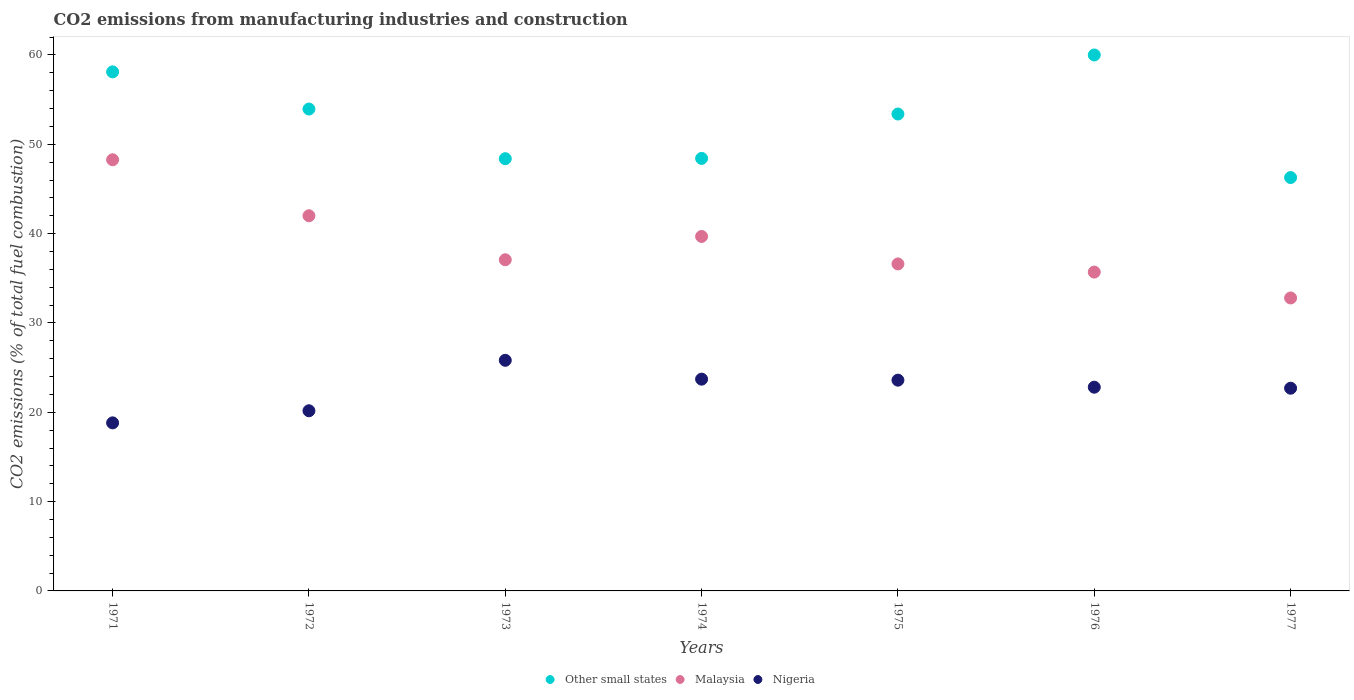How many different coloured dotlines are there?
Offer a terse response. 3. What is the amount of CO2 emitted in Nigeria in 1977?
Your response must be concise. 22.69. Across all years, what is the maximum amount of CO2 emitted in Malaysia?
Keep it short and to the point. 48.27. Across all years, what is the minimum amount of CO2 emitted in Other small states?
Keep it short and to the point. 46.28. What is the total amount of CO2 emitted in Malaysia in the graph?
Make the answer very short. 272.12. What is the difference between the amount of CO2 emitted in Other small states in 1974 and that in 1977?
Offer a very short reply. 2.14. What is the difference between the amount of CO2 emitted in Nigeria in 1971 and the amount of CO2 emitted in Other small states in 1976?
Make the answer very short. -41.19. What is the average amount of CO2 emitted in Malaysia per year?
Provide a succinct answer. 38.87. In the year 1975, what is the difference between the amount of CO2 emitted in Malaysia and amount of CO2 emitted in Nigeria?
Make the answer very short. 13.01. What is the ratio of the amount of CO2 emitted in Other small states in 1973 to that in 1976?
Make the answer very short. 0.81. Is the difference between the amount of CO2 emitted in Malaysia in 1975 and 1977 greater than the difference between the amount of CO2 emitted in Nigeria in 1975 and 1977?
Your answer should be compact. Yes. What is the difference between the highest and the second highest amount of CO2 emitted in Malaysia?
Provide a short and direct response. 6.27. What is the difference between the highest and the lowest amount of CO2 emitted in Malaysia?
Make the answer very short. 15.47. Is it the case that in every year, the sum of the amount of CO2 emitted in Malaysia and amount of CO2 emitted in Other small states  is greater than the amount of CO2 emitted in Nigeria?
Provide a short and direct response. Yes. Does the amount of CO2 emitted in Other small states monotonically increase over the years?
Keep it short and to the point. No. What is the difference between two consecutive major ticks on the Y-axis?
Your answer should be compact. 10. Are the values on the major ticks of Y-axis written in scientific E-notation?
Give a very brief answer. No. Does the graph contain any zero values?
Your response must be concise. No. How are the legend labels stacked?
Offer a very short reply. Horizontal. What is the title of the graph?
Offer a very short reply. CO2 emissions from manufacturing industries and construction. Does "Moldova" appear as one of the legend labels in the graph?
Provide a succinct answer. No. What is the label or title of the X-axis?
Ensure brevity in your answer.  Years. What is the label or title of the Y-axis?
Offer a very short reply. CO2 emissions (% of total fuel combustion). What is the CO2 emissions (% of total fuel combustion) of Other small states in 1971?
Your answer should be compact. 58.11. What is the CO2 emissions (% of total fuel combustion) in Malaysia in 1971?
Your response must be concise. 48.27. What is the CO2 emissions (% of total fuel combustion) of Nigeria in 1971?
Make the answer very short. 18.81. What is the CO2 emissions (% of total fuel combustion) in Other small states in 1972?
Your response must be concise. 53.95. What is the CO2 emissions (% of total fuel combustion) of Nigeria in 1972?
Give a very brief answer. 20.17. What is the CO2 emissions (% of total fuel combustion) in Other small states in 1973?
Give a very brief answer. 48.39. What is the CO2 emissions (% of total fuel combustion) of Malaysia in 1973?
Offer a very short reply. 37.07. What is the CO2 emissions (% of total fuel combustion) of Nigeria in 1973?
Give a very brief answer. 25.82. What is the CO2 emissions (% of total fuel combustion) of Other small states in 1974?
Your answer should be compact. 48.42. What is the CO2 emissions (% of total fuel combustion) of Malaysia in 1974?
Your answer should be compact. 39.68. What is the CO2 emissions (% of total fuel combustion) in Nigeria in 1974?
Give a very brief answer. 23.71. What is the CO2 emissions (% of total fuel combustion) in Other small states in 1975?
Your answer should be very brief. 53.39. What is the CO2 emissions (% of total fuel combustion) in Malaysia in 1975?
Offer a terse response. 36.61. What is the CO2 emissions (% of total fuel combustion) in Nigeria in 1975?
Make the answer very short. 23.59. What is the CO2 emissions (% of total fuel combustion) in Malaysia in 1976?
Keep it short and to the point. 35.69. What is the CO2 emissions (% of total fuel combustion) in Nigeria in 1976?
Ensure brevity in your answer.  22.81. What is the CO2 emissions (% of total fuel combustion) of Other small states in 1977?
Offer a very short reply. 46.28. What is the CO2 emissions (% of total fuel combustion) in Malaysia in 1977?
Make the answer very short. 32.8. What is the CO2 emissions (% of total fuel combustion) in Nigeria in 1977?
Keep it short and to the point. 22.69. Across all years, what is the maximum CO2 emissions (% of total fuel combustion) of Other small states?
Your response must be concise. 60. Across all years, what is the maximum CO2 emissions (% of total fuel combustion) of Malaysia?
Provide a succinct answer. 48.27. Across all years, what is the maximum CO2 emissions (% of total fuel combustion) in Nigeria?
Ensure brevity in your answer.  25.82. Across all years, what is the minimum CO2 emissions (% of total fuel combustion) in Other small states?
Your response must be concise. 46.28. Across all years, what is the minimum CO2 emissions (% of total fuel combustion) of Malaysia?
Your answer should be compact. 32.8. Across all years, what is the minimum CO2 emissions (% of total fuel combustion) in Nigeria?
Make the answer very short. 18.81. What is the total CO2 emissions (% of total fuel combustion) of Other small states in the graph?
Provide a short and direct response. 368.53. What is the total CO2 emissions (% of total fuel combustion) in Malaysia in the graph?
Provide a succinct answer. 272.12. What is the total CO2 emissions (% of total fuel combustion) in Nigeria in the graph?
Offer a very short reply. 157.6. What is the difference between the CO2 emissions (% of total fuel combustion) of Other small states in 1971 and that in 1972?
Provide a short and direct response. 4.16. What is the difference between the CO2 emissions (% of total fuel combustion) of Malaysia in 1971 and that in 1972?
Ensure brevity in your answer.  6.27. What is the difference between the CO2 emissions (% of total fuel combustion) of Nigeria in 1971 and that in 1972?
Give a very brief answer. -1.35. What is the difference between the CO2 emissions (% of total fuel combustion) in Other small states in 1971 and that in 1973?
Make the answer very short. 9.72. What is the difference between the CO2 emissions (% of total fuel combustion) in Malaysia in 1971 and that in 1973?
Keep it short and to the point. 11.19. What is the difference between the CO2 emissions (% of total fuel combustion) in Nigeria in 1971 and that in 1973?
Your response must be concise. -7. What is the difference between the CO2 emissions (% of total fuel combustion) in Other small states in 1971 and that in 1974?
Ensure brevity in your answer.  9.69. What is the difference between the CO2 emissions (% of total fuel combustion) in Malaysia in 1971 and that in 1974?
Keep it short and to the point. 8.59. What is the difference between the CO2 emissions (% of total fuel combustion) in Nigeria in 1971 and that in 1974?
Your answer should be compact. -4.89. What is the difference between the CO2 emissions (% of total fuel combustion) in Other small states in 1971 and that in 1975?
Keep it short and to the point. 4.72. What is the difference between the CO2 emissions (% of total fuel combustion) in Malaysia in 1971 and that in 1975?
Keep it short and to the point. 11.66. What is the difference between the CO2 emissions (% of total fuel combustion) in Nigeria in 1971 and that in 1975?
Offer a very short reply. -4.78. What is the difference between the CO2 emissions (% of total fuel combustion) in Other small states in 1971 and that in 1976?
Provide a succinct answer. -1.89. What is the difference between the CO2 emissions (% of total fuel combustion) in Malaysia in 1971 and that in 1976?
Your response must be concise. 12.57. What is the difference between the CO2 emissions (% of total fuel combustion) in Nigeria in 1971 and that in 1976?
Provide a succinct answer. -3.99. What is the difference between the CO2 emissions (% of total fuel combustion) of Other small states in 1971 and that in 1977?
Your response must be concise. 11.83. What is the difference between the CO2 emissions (% of total fuel combustion) in Malaysia in 1971 and that in 1977?
Offer a terse response. 15.47. What is the difference between the CO2 emissions (% of total fuel combustion) in Nigeria in 1971 and that in 1977?
Keep it short and to the point. -3.88. What is the difference between the CO2 emissions (% of total fuel combustion) in Other small states in 1972 and that in 1973?
Provide a succinct answer. 5.56. What is the difference between the CO2 emissions (% of total fuel combustion) of Malaysia in 1972 and that in 1973?
Your answer should be very brief. 4.93. What is the difference between the CO2 emissions (% of total fuel combustion) of Nigeria in 1972 and that in 1973?
Provide a short and direct response. -5.65. What is the difference between the CO2 emissions (% of total fuel combustion) in Other small states in 1972 and that in 1974?
Your answer should be very brief. 5.53. What is the difference between the CO2 emissions (% of total fuel combustion) of Malaysia in 1972 and that in 1974?
Provide a succinct answer. 2.32. What is the difference between the CO2 emissions (% of total fuel combustion) of Nigeria in 1972 and that in 1974?
Keep it short and to the point. -3.54. What is the difference between the CO2 emissions (% of total fuel combustion) in Other small states in 1972 and that in 1975?
Your response must be concise. 0.56. What is the difference between the CO2 emissions (% of total fuel combustion) of Malaysia in 1972 and that in 1975?
Give a very brief answer. 5.39. What is the difference between the CO2 emissions (% of total fuel combustion) of Nigeria in 1972 and that in 1975?
Ensure brevity in your answer.  -3.43. What is the difference between the CO2 emissions (% of total fuel combustion) in Other small states in 1972 and that in 1976?
Give a very brief answer. -6.05. What is the difference between the CO2 emissions (% of total fuel combustion) in Malaysia in 1972 and that in 1976?
Your answer should be very brief. 6.31. What is the difference between the CO2 emissions (% of total fuel combustion) of Nigeria in 1972 and that in 1976?
Give a very brief answer. -2.64. What is the difference between the CO2 emissions (% of total fuel combustion) of Other small states in 1972 and that in 1977?
Keep it short and to the point. 7.67. What is the difference between the CO2 emissions (% of total fuel combustion) in Malaysia in 1972 and that in 1977?
Make the answer very short. 9.2. What is the difference between the CO2 emissions (% of total fuel combustion) in Nigeria in 1972 and that in 1977?
Your response must be concise. -2.52. What is the difference between the CO2 emissions (% of total fuel combustion) of Other small states in 1973 and that in 1974?
Keep it short and to the point. -0.03. What is the difference between the CO2 emissions (% of total fuel combustion) of Malaysia in 1973 and that in 1974?
Your answer should be very brief. -2.61. What is the difference between the CO2 emissions (% of total fuel combustion) in Nigeria in 1973 and that in 1974?
Provide a short and direct response. 2.11. What is the difference between the CO2 emissions (% of total fuel combustion) of Other small states in 1973 and that in 1975?
Offer a terse response. -5. What is the difference between the CO2 emissions (% of total fuel combustion) of Malaysia in 1973 and that in 1975?
Offer a very short reply. 0.47. What is the difference between the CO2 emissions (% of total fuel combustion) of Nigeria in 1973 and that in 1975?
Keep it short and to the point. 2.22. What is the difference between the CO2 emissions (% of total fuel combustion) in Other small states in 1973 and that in 1976?
Provide a short and direct response. -11.61. What is the difference between the CO2 emissions (% of total fuel combustion) in Malaysia in 1973 and that in 1976?
Your answer should be very brief. 1.38. What is the difference between the CO2 emissions (% of total fuel combustion) of Nigeria in 1973 and that in 1976?
Offer a very short reply. 3.01. What is the difference between the CO2 emissions (% of total fuel combustion) in Other small states in 1973 and that in 1977?
Offer a very short reply. 2.11. What is the difference between the CO2 emissions (% of total fuel combustion) in Malaysia in 1973 and that in 1977?
Offer a terse response. 4.28. What is the difference between the CO2 emissions (% of total fuel combustion) of Nigeria in 1973 and that in 1977?
Ensure brevity in your answer.  3.12. What is the difference between the CO2 emissions (% of total fuel combustion) of Other small states in 1974 and that in 1975?
Offer a very short reply. -4.97. What is the difference between the CO2 emissions (% of total fuel combustion) in Malaysia in 1974 and that in 1975?
Ensure brevity in your answer.  3.08. What is the difference between the CO2 emissions (% of total fuel combustion) of Nigeria in 1974 and that in 1975?
Offer a very short reply. 0.11. What is the difference between the CO2 emissions (% of total fuel combustion) of Other small states in 1974 and that in 1976?
Make the answer very short. -11.58. What is the difference between the CO2 emissions (% of total fuel combustion) of Malaysia in 1974 and that in 1976?
Keep it short and to the point. 3.99. What is the difference between the CO2 emissions (% of total fuel combustion) of Nigeria in 1974 and that in 1976?
Offer a terse response. 0.9. What is the difference between the CO2 emissions (% of total fuel combustion) in Other small states in 1974 and that in 1977?
Your answer should be compact. 2.14. What is the difference between the CO2 emissions (% of total fuel combustion) of Malaysia in 1974 and that in 1977?
Your response must be concise. 6.89. What is the difference between the CO2 emissions (% of total fuel combustion) of Nigeria in 1974 and that in 1977?
Your answer should be very brief. 1.02. What is the difference between the CO2 emissions (% of total fuel combustion) in Other small states in 1975 and that in 1976?
Provide a succinct answer. -6.61. What is the difference between the CO2 emissions (% of total fuel combustion) of Malaysia in 1975 and that in 1976?
Your response must be concise. 0.91. What is the difference between the CO2 emissions (% of total fuel combustion) of Nigeria in 1975 and that in 1976?
Ensure brevity in your answer.  0.79. What is the difference between the CO2 emissions (% of total fuel combustion) in Other small states in 1975 and that in 1977?
Keep it short and to the point. 7.11. What is the difference between the CO2 emissions (% of total fuel combustion) in Malaysia in 1975 and that in 1977?
Offer a terse response. 3.81. What is the difference between the CO2 emissions (% of total fuel combustion) of Nigeria in 1975 and that in 1977?
Your answer should be compact. 0.9. What is the difference between the CO2 emissions (% of total fuel combustion) in Other small states in 1976 and that in 1977?
Make the answer very short. 13.72. What is the difference between the CO2 emissions (% of total fuel combustion) of Malaysia in 1976 and that in 1977?
Give a very brief answer. 2.9. What is the difference between the CO2 emissions (% of total fuel combustion) of Nigeria in 1976 and that in 1977?
Keep it short and to the point. 0.11. What is the difference between the CO2 emissions (% of total fuel combustion) of Other small states in 1971 and the CO2 emissions (% of total fuel combustion) of Malaysia in 1972?
Ensure brevity in your answer.  16.11. What is the difference between the CO2 emissions (% of total fuel combustion) of Other small states in 1971 and the CO2 emissions (% of total fuel combustion) of Nigeria in 1972?
Ensure brevity in your answer.  37.94. What is the difference between the CO2 emissions (% of total fuel combustion) in Malaysia in 1971 and the CO2 emissions (% of total fuel combustion) in Nigeria in 1972?
Your answer should be compact. 28.1. What is the difference between the CO2 emissions (% of total fuel combustion) in Other small states in 1971 and the CO2 emissions (% of total fuel combustion) in Malaysia in 1973?
Your response must be concise. 21.03. What is the difference between the CO2 emissions (% of total fuel combustion) in Other small states in 1971 and the CO2 emissions (% of total fuel combustion) in Nigeria in 1973?
Keep it short and to the point. 32.29. What is the difference between the CO2 emissions (% of total fuel combustion) of Malaysia in 1971 and the CO2 emissions (% of total fuel combustion) of Nigeria in 1973?
Your answer should be very brief. 22.45. What is the difference between the CO2 emissions (% of total fuel combustion) in Other small states in 1971 and the CO2 emissions (% of total fuel combustion) in Malaysia in 1974?
Your response must be concise. 18.43. What is the difference between the CO2 emissions (% of total fuel combustion) in Other small states in 1971 and the CO2 emissions (% of total fuel combustion) in Nigeria in 1974?
Make the answer very short. 34.4. What is the difference between the CO2 emissions (% of total fuel combustion) of Malaysia in 1971 and the CO2 emissions (% of total fuel combustion) of Nigeria in 1974?
Provide a succinct answer. 24.56. What is the difference between the CO2 emissions (% of total fuel combustion) in Other small states in 1971 and the CO2 emissions (% of total fuel combustion) in Malaysia in 1975?
Keep it short and to the point. 21.5. What is the difference between the CO2 emissions (% of total fuel combustion) of Other small states in 1971 and the CO2 emissions (% of total fuel combustion) of Nigeria in 1975?
Your answer should be very brief. 34.51. What is the difference between the CO2 emissions (% of total fuel combustion) in Malaysia in 1971 and the CO2 emissions (% of total fuel combustion) in Nigeria in 1975?
Give a very brief answer. 24.67. What is the difference between the CO2 emissions (% of total fuel combustion) of Other small states in 1971 and the CO2 emissions (% of total fuel combustion) of Malaysia in 1976?
Provide a succinct answer. 22.41. What is the difference between the CO2 emissions (% of total fuel combustion) of Other small states in 1971 and the CO2 emissions (% of total fuel combustion) of Nigeria in 1976?
Offer a terse response. 35.3. What is the difference between the CO2 emissions (% of total fuel combustion) of Malaysia in 1971 and the CO2 emissions (% of total fuel combustion) of Nigeria in 1976?
Your answer should be compact. 25.46. What is the difference between the CO2 emissions (% of total fuel combustion) in Other small states in 1971 and the CO2 emissions (% of total fuel combustion) in Malaysia in 1977?
Offer a very short reply. 25.31. What is the difference between the CO2 emissions (% of total fuel combustion) in Other small states in 1971 and the CO2 emissions (% of total fuel combustion) in Nigeria in 1977?
Keep it short and to the point. 35.42. What is the difference between the CO2 emissions (% of total fuel combustion) of Malaysia in 1971 and the CO2 emissions (% of total fuel combustion) of Nigeria in 1977?
Give a very brief answer. 25.57. What is the difference between the CO2 emissions (% of total fuel combustion) in Other small states in 1972 and the CO2 emissions (% of total fuel combustion) in Malaysia in 1973?
Your answer should be very brief. 16.87. What is the difference between the CO2 emissions (% of total fuel combustion) of Other small states in 1972 and the CO2 emissions (% of total fuel combustion) of Nigeria in 1973?
Your answer should be compact. 28.13. What is the difference between the CO2 emissions (% of total fuel combustion) of Malaysia in 1972 and the CO2 emissions (% of total fuel combustion) of Nigeria in 1973?
Make the answer very short. 16.18. What is the difference between the CO2 emissions (% of total fuel combustion) of Other small states in 1972 and the CO2 emissions (% of total fuel combustion) of Malaysia in 1974?
Offer a very short reply. 14.26. What is the difference between the CO2 emissions (% of total fuel combustion) in Other small states in 1972 and the CO2 emissions (% of total fuel combustion) in Nigeria in 1974?
Your answer should be very brief. 30.24. What is the difference between the CO2 emissions (% of total fuel combustion) in Malaysia in 1972 and the CO2 emissions (% of total fuel combustion) in Nigeria in 1974?
Your answer should be compact. 18.29. What is the difference between the CO2 emissions (% of total fuel combustion) in Other small states in 1972 and the CO2 emissions (% of total fuel combustion) in Malaysia in 1975?
Provide a succinct answer. 17.34. What is the difference between the CO2 emissions (% of total fuel combustion) in Other small states in 1972 and the CO2 emissions (% of total fuel combustion) in Nigeria in 1975?
Offer a terse response. 30.35. What is the difference between the CO2 emissions (% of total fuel combustion) in Malaysia in 1972 and the CO2 emissions (% of total fuel combustion) in Nigeria in 1975?
Provide a succinct answer. 18.41. What is the difference between the CO2 emissions (% of total fuel combustion) of Other small states in 1972 and the CO2 emissions (% of total fuel combustion) of Malaysia in 1976?
Provide a succinct answer. 18.25. What is the difference between the CO2 emissions (% of total fuel combustion) of Other small states in 1972 and the CO2 emissions (% of total fuel combustion) of Nigeria in 1976?
Your answer should be very brief. 31.14. What is the difference between the CO2 emissions (% of total fuel combustion) in Malaysia in 1972 and the CO2 emissions (% of total fuel combustion) in Nigeria in 1976?
Your answer should be compact. 19.19. What is the difference between the CO2 emissions (% of total fuel combustion) in Other small states in 1972 and the CO2 emissions (% of total fuel combustion) in Malaysia in 1977?
Provide a short and direct response. 21.15. What is the difference between the CO2 emissions (% of total fuel combustion) of Other small states in 1972 and the CO2 emissions (% of total fuel combustion) of Nigeria in 1977?
Your answer should be compact. 31.25. What is the difference between the CO2 emissions (% of total fuel combustion) of Malaysia in 1972 and the CO2 emissions (% of total fuel combustion) of Nigeria in 1977?
Your answer should be compact. 19.31. What is the difference between the CO2 emissions (% of total fuel combustion) in Other small states in 1973 and the CO2 emissions (% of total fuel combustion) in Malaysia in 1974?
Give a very brief answer. 8.7. What is the difference between the CO2 emissions (% of total fuel combustion) of Other small states in 1973 and the CO2 emissions (% of total fuel combustion) of Nigeria in 1974?
Your answer should be very brief. 24.68. What is the difference between the CO2 emissions (% of total fuel combustion) of Malaysia in 1973 and the CO2 emissions (% of total fuel combustion) of Nigeria in 1974?
Your response must be concise. 13.37. What is the difference between the CO2 emissions (% of total fuel combustion) in Other small states in 1973 and the CO2 emissions (% of total fuel combustion) in Malaysia in 1975?
Ensure brevity in your answer.  11.78. What is the difference between the CO2 emissions (% of total fuel combustion) in Other small states in 1973 and the CO2 emissions (% of total fuel combustion) in Nigeria in 1975?
Provide a succinct answer. 24.79. What is the difference between the CO2 emissions (% of total fuel combustion) of Malaysia in 1973 and the CO2 emissions (% of total fuel combustion) of Nigeria in 1975?
Offer a terse response. 13.48. What is the difference between the CO2 emissions (% of total fuel combustion) of Other small states in 1973 and the CO2 emissions (% of total fuel combustion) of Malaysia in 1976?
Give a very brief answer. 12.69. What is the difference between the CO2 emissions (% of total fuel combustion) in Other small states in 1973 and the CO2 emissions (% of total fuel combustion) in Nigeria in 1976?
Ensure brevity in your answer.  25.58. What is the difference between the CO2 emissions (% of total fuel combustion) of Malaysia in 1973 and the CO2 emissions (% of total fuel combustion) of Nigeria in 1976?
Provide a succinct answer. 14.27. What is the difference between the CO2 emissions (% of total fuel combustion) of Other small states in 1973 and the CO2 emissions (% of total fuel combustion) of Malaysia in 1977?
Ensure brevity in your answer.  15.59. What is the difference between the CO2 emissions (% of total fuel combustion) of Other small states in 1973 and the CO2 emissions (% of total fuel combustion) of Nigeria in 1977?
Offer a terse response. 25.69. What is the difference between the CO2 emissions (% of total fuel combustion) of Malaysia in 1973 and the CO2 emissions (% of total fuel combustion) of Nigeria in 1977?
Ensure brevity in your answer.  14.38. What is the difference between the CO2 emissions (% of total fuel combustion) of Other small states in 1974 and the CO2 emissions (% of total fuel combustion) of Malaysia in 1975?
Your answer should be compact. 11.81. What is the difference between the CO2 emissions (% of total fuel combustion) of Other small states in 1974 and the CO2 emissions (% of total fuel combustion) of Nigeria in 1975?
Provide a succinct answer. 24.83. What is the difference between the CO2 emissions (% of total fuel combustion) of Malaysia in 1974 and the CO2 emissions (% of total fuel combustion) of Nigeria in 1975?
Your response must be concise. 16.09. What is the difference between the CO2 emissions (% of total fuel combustion) in Other small states in 1974 and the CO2 emissions (% of total fuel combustion) in Malaysia in 1976?
Offer a very short reply. 12.73. What is the difference between the CO2 emissions (% of total fuel combustion) of Other small states in 1974 and the CO2 emissions (% of total fuel combustion) of Nigeria in 1976?
Keep it short and to the point. 25.61. What is the difference between the CO2 emissions (% of total fuel combustion) in Malaysia in 1974 and the CO2 emissions (% of total fuel combustion) in Nigeria in 1976?
Provide a short and direct response. 16.88. What is the difference between the CO2 emissions (% of total fuel combustion) of Other small states in 1974 and the CO2 emissions (% of total fuel combustion) of Malaysia in 1977?
Give a very brief answer. 15.62. What is the difference between the CO2 emissions (% of total fuel combustion) in Other small states in 1974 and the CO2 emissions (% of total fuel combustion) in Nigeria in 1977?
Give a very brief answer. 25.73. What is the difference between the CO2 emissions (% of total fuel combustion) of Malaysia in 1974 and the CO2 emissions (% of total fuel combustion) of Nigeria in 1977?
Provide a succinct answer. 16.99. What is the difference between the CO2 emissions (% of total fuel combustion) of Other small states in 1975 and the CO2 emissions (% of total fuel combustion) of Malaysia in 1976?
Give a very brief answer. 17.7. What is the difference between the CO2 emissions (% of total fuel combustion) of Other small states in 1975 and the CO2 emissions (% of total fuel combustion) of Nigeria in 1976?
Your answer should be very brief. 30.58. What is the difference between the CO2 emissions (% of total fuel combustion) of Malaysia in 1975 and the CO2 emissions (% of total fuel combustion) of Nigeria in 1976?
Your answer should be compact. 13.8. What is the difference between the CO2 emissions (% of total fuel combustion) of Other small states in 1975 and the CO2 emissions (% of total fuel combustion) of Malaysia in 1977?
Provide a short and direct response. 20.59. What is the difference between the CO2 emissions (% of total fuel combustion) in Other small states in 1975 and the CO2 emissions (% of total fuel combustion) in Nigeria in 1977?
Your response must be concise. 30.7. What is the difference between the CO2 emissions (% of total fuel combustion) of Malaysia in 1975 and the CO2 emissions (% of total fuel combustion) of Nigeria in 1977?
Your answer should be very brief. 13.91. What is the difference between the CO2 emissions (% of total fuel combustion) of Other small states in 1976 and the CO2 emissions (% of total fuel combustion) of Malaysia in 1977?
Your answer should be compact. 27.2. What is the difference between the CO2 emissions (% of total fuel combustion) of Other small states in 1976 and the CO2 emissions (% of total fuel combustion) of Nigeria in 1977?
Give a very brief answer. 37.31. What is the difference between the CO2 emissions (% of total fuel combustion) in Malaysia in 1976 and the CO2 emissions (% of total fuel combustion) in Nigeria in 1977?
Keep it short and to the point. 13. What is the average CO2 emissions (% of total fuel combustion) of Other small states per year?
Make the answer very short. 52.65. What is the average CO2 emissions (% of total fuel combustion) of Malaysia per year?
Keep it short and to the point. 38.87. What is the average CO2 emissions (% of total fuel combustion) in Nigeria per year?
Give a very brief answer. 22.51. In the year 1971, what is the difference between the CO2 emissions (% of total fuel combustion) of Other small states and CO2 emissions (% of total fuel combustion) of Malaysia?
Provide a succinct answer. 9.84. In the year 1971, what is the difference between the CO2 emissions (% of total fuel combustion) of Other small states and CO2 emissions (% of total fuel combustion) of Nigeria?
Provide a short and direct response. 39.29. In the year 1971, what is the difference between the CO2 emissions (% of total fuel combustion) of Malaysia and CO2 emissions (% of total fuel combustion) of Nigeria?
Keep it short and to the point. 29.45. In the year 1972, what is the difference between the CO2 emissions (% of total fuel combustion) of Other small states and CO2 emissions (% of total fuel combustion) of Malaysia?
Offer a very short reply. 11.95. In the year 1972, what is the difference between the CO2 emissions (% of total fuel combustion) of Other small states and CO2 emissions (% of total fuel combustion) of Nigeria?
Make the answer very short. 33.78. In the year 1972, what is the difference between the CO2 emissions (% of total fuel combustion) in Malaysia and CO2 emissions (% of total fuel combustion) in Nigeria?
Your response must be concise. 21.83. In the year 1973, what is the difference between the CO2 emissions (% of total fuel combustion) of Other small states and CO2 emissions (% of total fuel combustion) of Malaysia?
Keep it short and to the point. 11.31. In the year 1973, what is the difference between the CO2 emissions (% of total fuel combustion) of Other small states and CO2 emissions (% of total fuel combustion) of Nigeria?
Keep it short and to the point. 22.57. In the year 1973, what is the difference between the CO2 emissions (% of total fuel combustion) of Malaysia and CO2 emissions (% of total fuel combustion) of Nigeria?
Your answer should be compact. 11.26. In the year 1974, what is the difference between the CO2 emissions (% of total fuel combustion) of Other small states and CO2 emissions (% of total fuel combustion) of Malaysia?
Ensure brevity in your answer.  8.74. In the year 1974, what is the difference between the CO2 emissions (% of total fuel combustion) of Other small states and CO2 emissions (% of total fuel combustion) of Nigeria?
Provide a short and direct response. 24.71. In the year 1974, what is the difference between the CO2 emissions (% of total fuel combustion) in Malaysia and CO2 emissions (% of total fuel combustion) in Nigeria?
Make the answer very short. 15.97. In the year 1975, what is the difference between the CO2 emissions (% of total fuel combustion) in Other small states and CO2 emissions (% of total fuel combustion) in Malaysia?
Give a very brief answer. 16.78. In the year 1975, what is the difference between the CO2 emissions (% of total fuel combustion) in Other small states and CO2 emissions (% of total fuel combustion) in Nigeria?
Keep it short and to the point. 29.8. In the year 1975, what is the difference between the CO2 emissions (% of total fuel combustion) of Malaysia and CO2 emissions (% of total fuel combustion) of Nigeria?
Keep it short and to the point. 13.01. In the year 1976, what is the difference between the CO2 emissions (% of total fuel combustion) of Other small states and CO2 emissions (% of total fuel combustion) of Malaysia?
Ensure brevity in your answer.  24.31. In the year 1976, what is the difference between the CO2 emissions (% of total fuel combustion) of Other small states and CO2 emissions (% of total fuel combustion) of Nigeria?
Provide a short and direct response. 37.19. In the year 1976, what is the difference between the CO2 emissions (% of total fuel combustion) in Malaysia and CO2 emissions (% of total fuel combustion) in Nigeria?
Your answer should be compact. 12.89. In the year 1977, what is the difference between the CO2 emissions (% of total fuel combustion) of Other small states and CO2 emissions (% of total fuel combustion) of Malaysia?
Your answer should be very brief. 13.48. In the year 1977, what is the difference between the CO2 emissions (% of total fuel combustion) of Other small states and CO2 emissions (% of total fuel combustion) of Nigeria?
Provide a short and direct response. 23.58. In the year 1977, what is the difference between the CO2 emissions (% of total fuel combustion) in Malaysia and CO2 emissions (% of total fuel combustion) in Nigeria?
Offer a very short reply. 10.1. What is the ratio of the CO2 emissions (% of total fuel combustion) of Other small states in 1971 to that in 1972?
Keep it short and to the point. 1.08. What is the ratio of the CO2 emissions (% of total fuel combustion) in Malaysia in 1971 to that in 1972?
Provide a succinct answer. 1.15. What is the ratio of the CO2 emissions (% of total fuel combustion) in Nigeria in 1971 to that in 1972?
Your answer should be very brief. 0.93. What is the ratio of the CO2 emissions (% of total fuel combustion) of Other small states in 1971 to that in 1973?
Provide a short and direct response. 1.2. What is the ratio of the CO2 emissions (% of total fuel combustion) of Malaysia in 1971 to that in 1973?
Provide a succinct answer. 1.3. What is the ratio of the CO2 emissions (% of total fuel combustion) of Nigeria in 1971 to that in 1973?
Offer a terse response. 0.73. What is the ratio of the CO2 emissions (% of total fuel combustion) of Other small states in 1971 to that in 1974?
Ensure brevity in your answer.  1.2. What is the ratio of the CO2 emissions (% of total fuel combustion) in Malaysia in 1971 to that in 1974?
Your response must be concise. 1.22. What is the ratio of the CO2 emissions (% of total fuel combustion) in Nigeria in 1971 to that in 1974?
Offer a very short reply. 0.79. What is the ratio of the CO2 emissions (% of total fuel combustion) in Other small states in 1971 to that in 1975?
Offer a terse response. 1.09. What is the ratio of the CO2 emissions (% of total fuel combustion) in Malaysia in 1971 to that in 1975?
Make the answer very short. 1.32. What is the ratio of the CO2 emissions (% of total fuel combustion) in Nigeria in 1971 to that in 1975?
Keep it short and to the point. 0.8. What is the ratio of the CO2 emissions (% of total fuel combustion) in Other small states in 1971 to that in 1976?
Your answer should be compact. 0.97. What is the ratio of the CO2 emissions (% of total fuel combustion) in Malaysia in 1971 to that in 1976?
Provide a short and direct response. 1.35. What is the ratio of the CO2 emissions (% of total fuel combustion) of Nigeria in 1971 to that in 1976?
Provide a short and direct response. 0.82. What is the ratio of the CO2 emissions (% of total fuel combustion) in Other small states in 1971 to that in 1977?
Give a very brief answer. 1.26. What is the ratio of the CO2 emissions (% of total fuel combustion) in Malaysia in 1971 to that in 1977?
Make the answer very short. 1.47. What is the ratio of the CO2 emissions (% of total fuel combustion) in Nigeria in 1971 to that in 1977?
Provide a short and direct response. 0.83. What is the ratio of the CO2 emissions (% of total fuel combustion) of Other small states in 1972 to that in 1973?
Ensure brevity in your answer.  1.11. What is the ratio of the CO2 emissions (% of total fuel combustion) in Malaysia in 1972 to that in 1973?
Make the answer very short. 1.13. What is the ratio of the CO2 emissions (% of total fuel combustion) of Nigeria in 1972 to that in 1973?
Give a very brief answer. 0.78. What is the ratio of the CO2 emissions (% of total fuel combustion) in Other small states in 1972 to that in 1974?
Provide a succinct answer. 1.11. What is the ratio of the CO2 emissions (% of total fuel combustion) of Malaysia in 1972 to that in 1974?
Your answer should be very brief. 1.06. What is the ratio of the CO2 emissions (% of total fuel combustion) in Nigeria in 1972 to that in 1974?
Your answer should be compact. 0.85. What is the ratio of the CO2 emissions (% of total fuel combustion) in Other small states in 1972 to that in 1975?
Ensure brevity in your answer.  1.01. What is the ratio of the CO2 emissions (% of total fuel combustion) of Malaysia in 1972 to that in 1975?
Give a very brief answer. 1.15. What is the ratio of the CO2 emissions (% of total fuel combustion) in Nigeria in 1972 to that in 1975?
Ensure brevity in your answer.  0.85. What is the ratio of the CO2 emissions (% of total fuel combustion) of Other small states in 1972 to that in 1976?
Your answer should be very brief. 0.9. What is the ratio of the CO2 emissions (% of total fuel combustion) of Malaysia in 1972 to that in 1976?
Ensure brevity in your answer.  1.18. What is the ratio of the CO2 emissions (% of total fuel combustion) of Nigeria in 1972 to that in 1976?
Keep it short and to the point. 0.88. What is the ratio of the CO2 emissions (% of total fuel combustion) in Other small states in 1972 to that in 1977?
Ensure brevity in your answer.  1.17. What is the ratio of the CO2 emissions (% of total fuel combustion) of Malaysia in 1972 to that in 1977?
Make the answer very short. 1.28. What is the ratio of the CO2 emissions (% of total fuel combustion) in Nigeria in 1972 to that in 1977?
Offer a very short reply. 0.89. What is the ratio of the CO2 emissions (% of total fuel combustion) of Other small states in 1973 to that in 1974?
Keep it short and to the point. 1. What is the ratio of the CO2 emissions (% of total fuel combustion) in Malaysia in 1973 to that in 1974?
Ensure brevity in your answer.  0.93. What is the ratio of the CO2 emissions (% of total fuel combustion) of Nigeria in 1973 to that in 1974?
Offer a terse response. 1.09. What is the ratio of the CO2 emissions (% of total fuel combustion) of Other small states in 1973 to that in 1975?
Make the answer very short. 0.91. What is the ratio of the CO2 emissions (% of total fuel combustion) in Malaysia in 1973 to that in 1975?
Your response must be concise. 1.01. What is the ratio of the CO2 emissions (% of total fuel combustion) of Nigeria in 1973 to that in 1975?
Your answer should be compact. 1.09. What is the ratio of the CO2 emissions (% of total fuel combustion) in Other small states in 1973 to that in 1976?
Keep it short and to the point. 0.81. What is the ratio of the CO2 emissions (% of total fuel combustion) in Malaysia in 1973 to that in 1976?
Offer a terse response. 1.04. What is the ratio of the CO2 emissions (% of total fuel combustion) in Nigeria in 1973 to that in 1976?
Your answer should be compact. 1.13. What is the ratio of the CO2 emissions (% of total fuel combustion) of Other small states in 1973 to that in 1977?
Give a very brief answer. 1.05. What is the ratio of the CO2 emissions (% of total fuel combustion) in Malaysia in 1973 to that in 1977?
Give a very brief answer. 1.13. What is the ratio of the CO2 emissions (% of total fuel combustion) of Nigeria in 1973 to that in 1977?
Offer a very short reply. 1.14. What is the ratio of the CO2 emissions (% of total fuel combustion) of Other small states in 1974 to that in 1975?
Make the answer very short. 0.91. What is the ratio of the CO2 emissions (% of total fuel combustion) in Malaysia in 1974 to that in 1975?
Your response must be concise. 1.08. What is the ratio of the CO2 emissions (% of total fuel combustion) of Other small states in 1974 to that in 1976?
Offer a terse response. 0.81. What is the ratio of the CO2 emissions (% of total fuel combustion) of Malaysia in 1974 to that in 1976?
Offer a very short reply. 1.11. What is the ratio of the CO2 emissions (% of total fuel combustion) of Nigeria in 1974 to that in 1976?
Offer a very short reply. 1.04. What is the ratio of the CO2 emissions (% of total fuel combustion) in Other small states in 1974 to that in 1977?
Ensure brevity in your answer.  1.05. What is the ratio of the CO2 emissions (% of total fuel combustion) of Malaysia in 1974 to that in 1977?
Your answer should be compact. 1.21. What is the ratio of the CO2 emissions (% of total fuel combustion) in Nigeria in 1974 to that in 1977?
Offer a very short reply. 1.04. What is the ratio of the CO2 emissions (% of total fuel combustion) in Other small states in 1975 to that in 1976?
Your answer should be compact. 0.89. What is the ratio of the CO2 emissions (% of total fuel combustion) of Malaysia in 1975 to that in 1976?
Ensure brevity in your answer.  1.03. What is the ratio of the CO2 emissions (% of total fuel combustion) in Nigeria in 1975 to that in 1976?
Provide a short and direct response. 1.03. What is the ratio of the CO2 emissions (% of total fuel combustion) in Other small states in 1975 to that in 1977?
Offer a terse response. 1.15. What is the ratio of the CO2 emissions (% of total fuel combustion) in Malaysia in 1975 to that in 1977?
Offer a very short reply. 1.12. What is the ratio of the CO2 emissions (% of total fuel combustion) in Nigeria in 1975 to that in 1977?
Make the answer very short. 1.04. What is the ratio of the CO2 emissions (% of total fuel combustion) in Other small states in 1976 to that in 1977?
Keep it short and to the point. 1.3. What is the ratio of the CO2 emissions (% of total fuel combustion) of Malaysia in 1976 to that in 1977?
Make the answer very short. 1.09. What is the ratio of the CO2 emissions (% of total fuel combustion) in Nigeria in 1976 to that in 1977?
Offer a terse response. 1. What is the difference between the highest and the second highest CO2 emissions (% of total fuel combustion) of Other small states?
Make the answer very short. 1.89. What is the difference between the highest and the second highest CO2 emissions (% of total fuel combustion) of Malaysia?
Provide a succinct answer. 6.27. What is the difference between the highest and the second highest CO2 emissions (% of total fuel combustion) in Nigeria?
Your answer should be very brief. 2.11. What is the difference between the highest and the lowest CO2 emissions (% of total fuel combustion) of Other small states?
Ensure brevity in your answer.  13.72. What is the difference between the highest and the lowest CO2 emissions (% of total fuel combustion) of Malaysia?
Provide a short and direct response. 15.47. What is the difference between the highest and the lowest CO2 emissions (% of total fuel combustion) of Nigeria?
Offer a terse response. 7. 